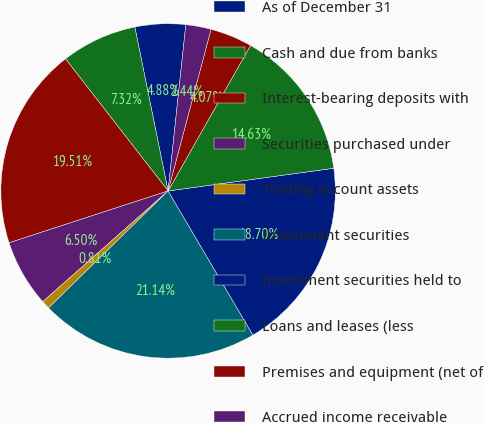Convert chart. <chart><loc_0><loc_0><loc_500><loc_500><pie_chart><fcel>As of December 31<fcel>Cash and due from banks<fcel>Interest-bearing deposits with<fcel>Securities purchased under<fcel>Trading account assets<fcel>Investment securities<fcel>Investment securities held to<fcel>Loans and leases (less<fcel>Premises and equipment (net of<fcel>Accrued income receivable<nl><fcel>4.88%<fcel>7.32%<fcel>19.51%<fcel>6.5%<fcel>0.81%<fcel>21.14%<fcel>18.7%<fcel>14.63%<fcel>4.07%<fcel>2.44%<nl></chart> 